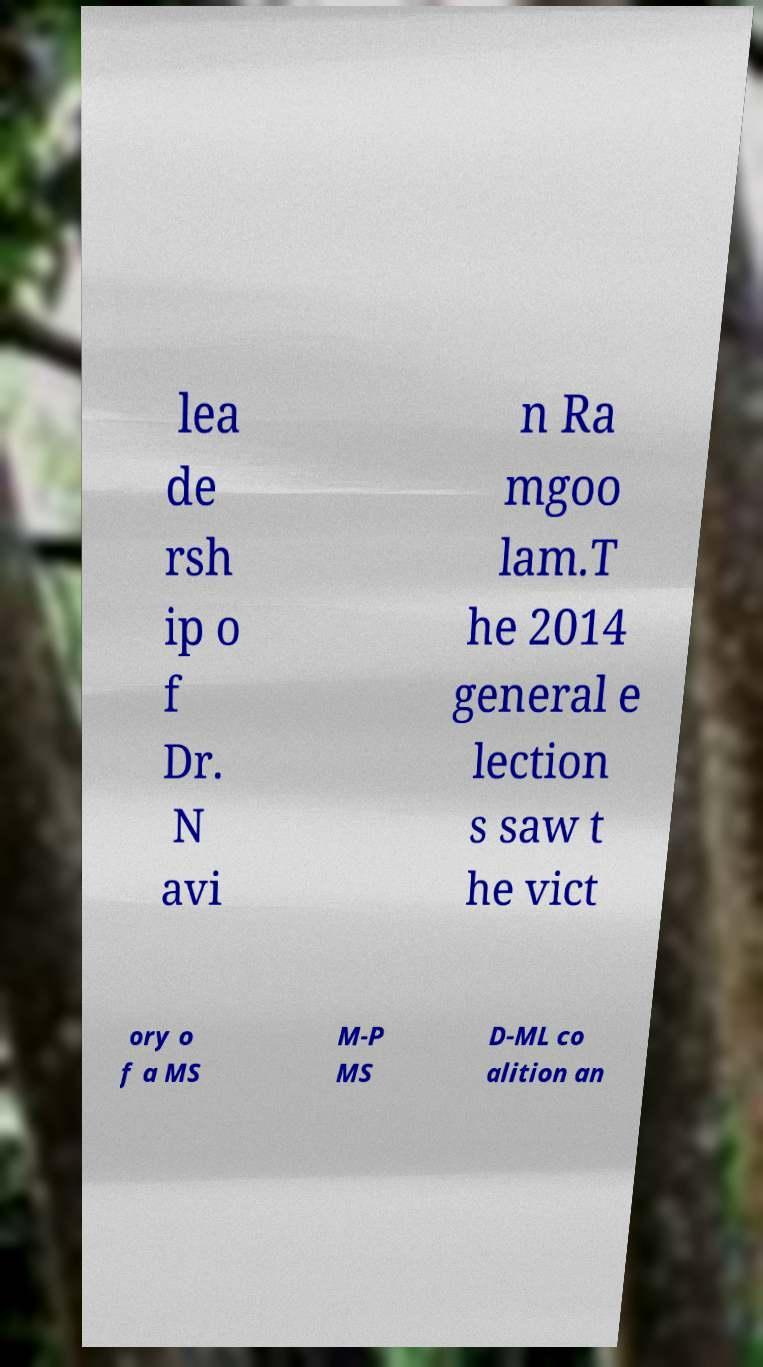Please read and relay the text visible in this image. What does it say? lea de rsh ip o f Dr. N avi n Ra mgoo lam.T he 2014 general e lection s saw t he vict ory o f a MS M-P MS D-ML co alition an 